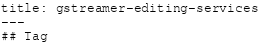Convert code to text. <code><loc_0><loc_0><loc_500><loc_500><_HTML_>title: gstreamer-editing-services
---
## Tag</code> 